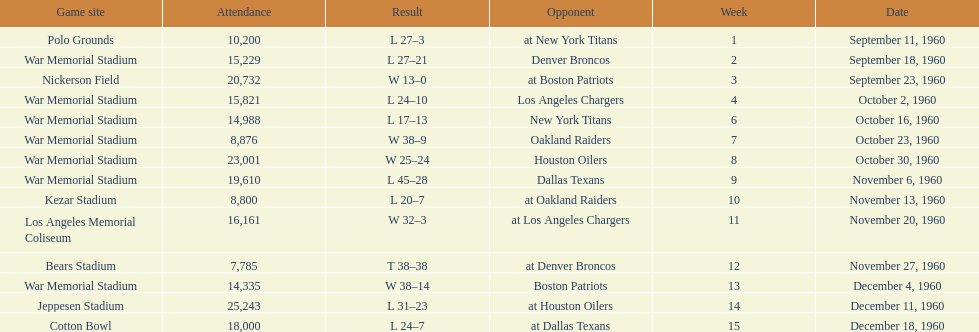What was the largest difference of points in a single game? 29. 